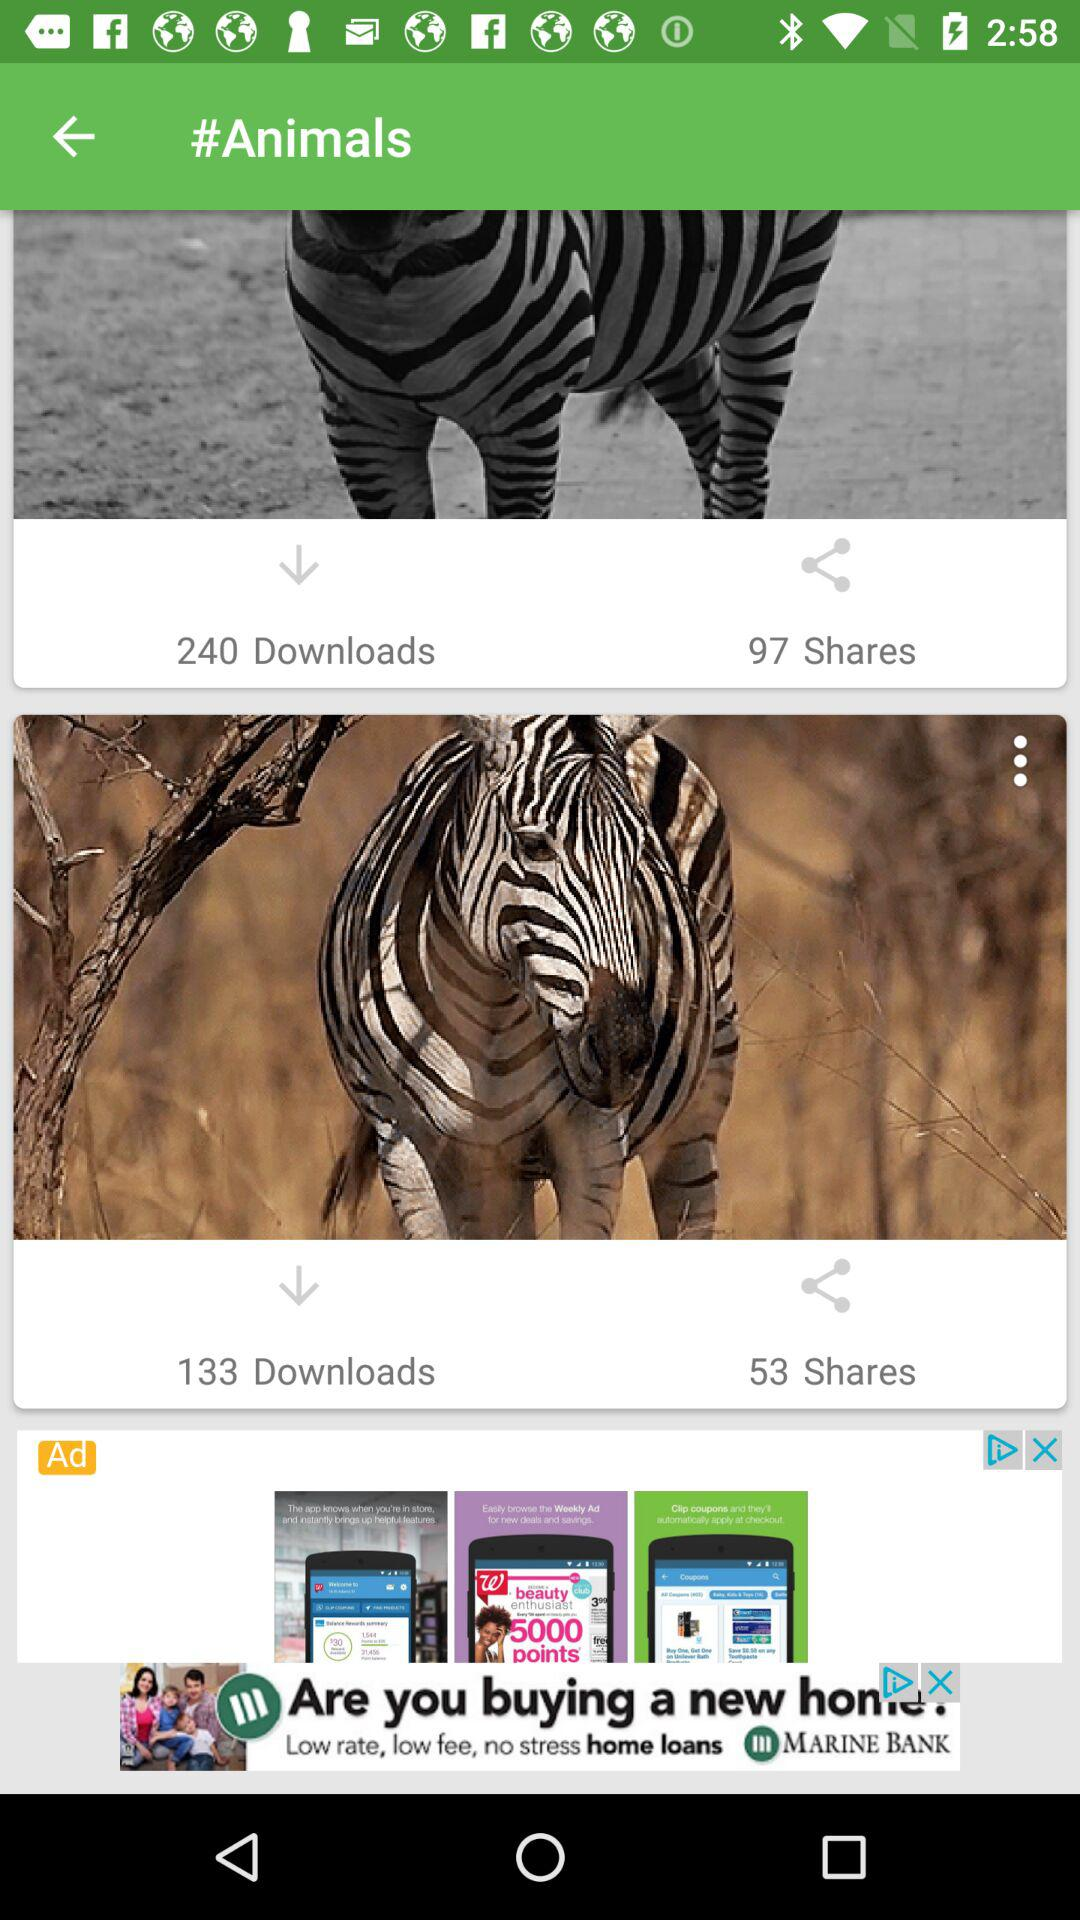How many more downloads does the zebra standing on the dirt road have than the zebra standing in the grass?
Answer the question using a single word or phrase. 107 